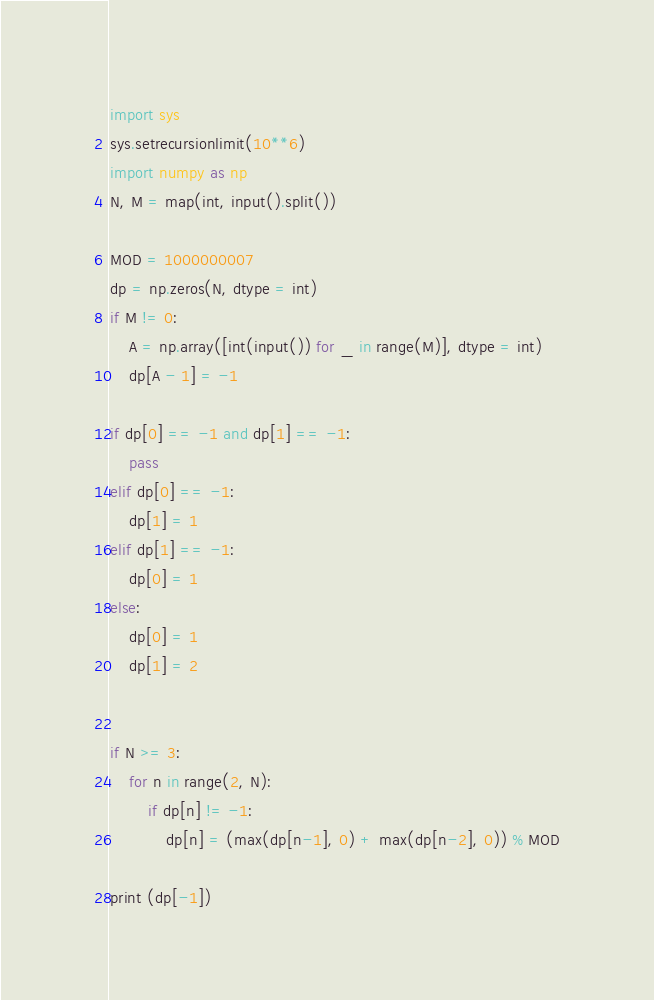Convert code to text. <code><loc_0><loc_0><loc_500><loc_500><_Python_>import sys
sys.setrecursionlimit(10**6)
import numpy as np
N, M = map(int, input().split())

MOD = 1000000007
dp = np.zeros(N, dtype = int)
if M != 0:
    A = np.array([int(input()) for _ in range(M)], dtype = int)
    dp[A - 1] = -1

if dp[0] == -1 and dp[1] == -1:
    pass
elif dp[0] == -1:
    dp[1] = 1
elif dp[1] == -1:
    dp[0] = 1
else:
    dp[0] = 1
    dp[1] = 2


if N >= 3:
    for n in range(2, N):
        if dp[n] != -1:
            dp[n] = (max(dp[n-1], 0) + max(dp[n-2], 0)) % MOD

print (dp[-1])
</code> 